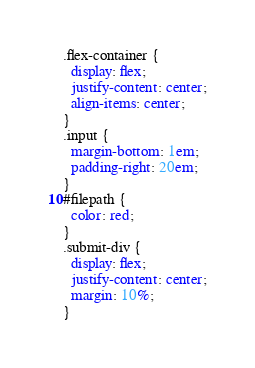Convert code to text. <code><loc_0><loc_0><loc_500><loc_500><_CSS_>.flex-container {
  display: flex;
  justify-content: center;
  align-items: center;
}
.input {
  margin-bottom: 1em;
  padding-right: 20em;
}
#filepath {
  color: red;
}
.submit-div {
  display: flex;
  justify-content: center;
  margin: 10%;
}
</code> 